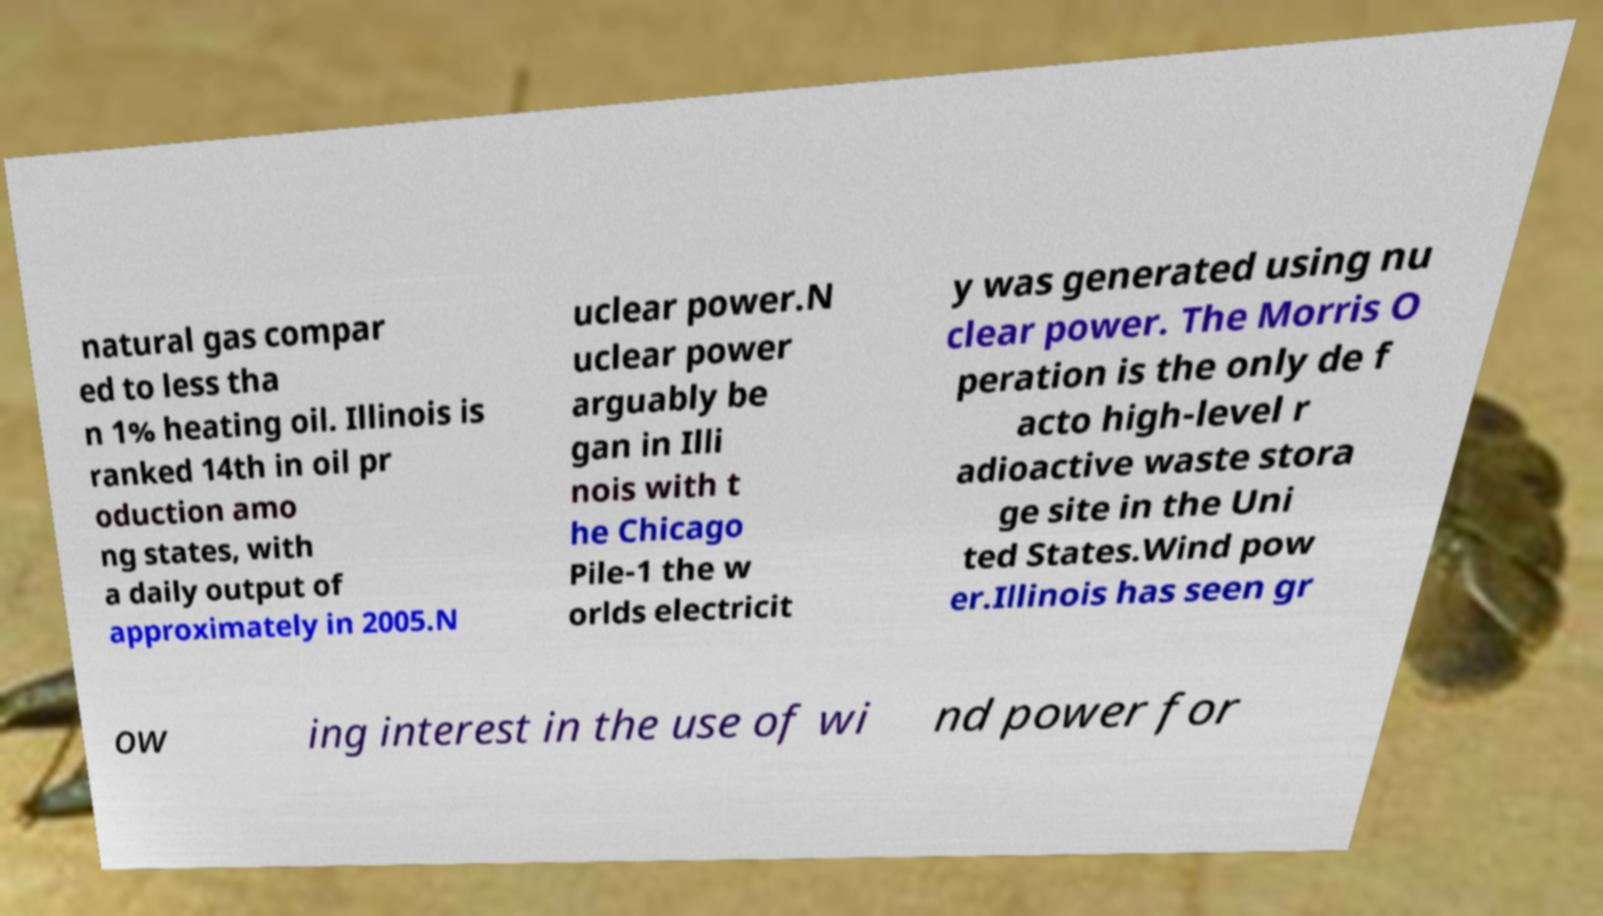Could you extract and type out the text from this image? natural gas compar ed to less tha n 1% heating oil. Illinois is ranked 14th in oil pr oduction amo ng states, with a daily output of approximately in 2005.N uclear power.N uclear power arguably be gan in Illi nois with t he Chicago Pile-1 the w orlds electricit y was generated using nu clear power. The Morris O peration is the only de f acto high-level r adioactive waste stora ge site in the Uni ted States.Wind pow er.Illinois has seen gr ow ing interest in the use of wi nd power for 